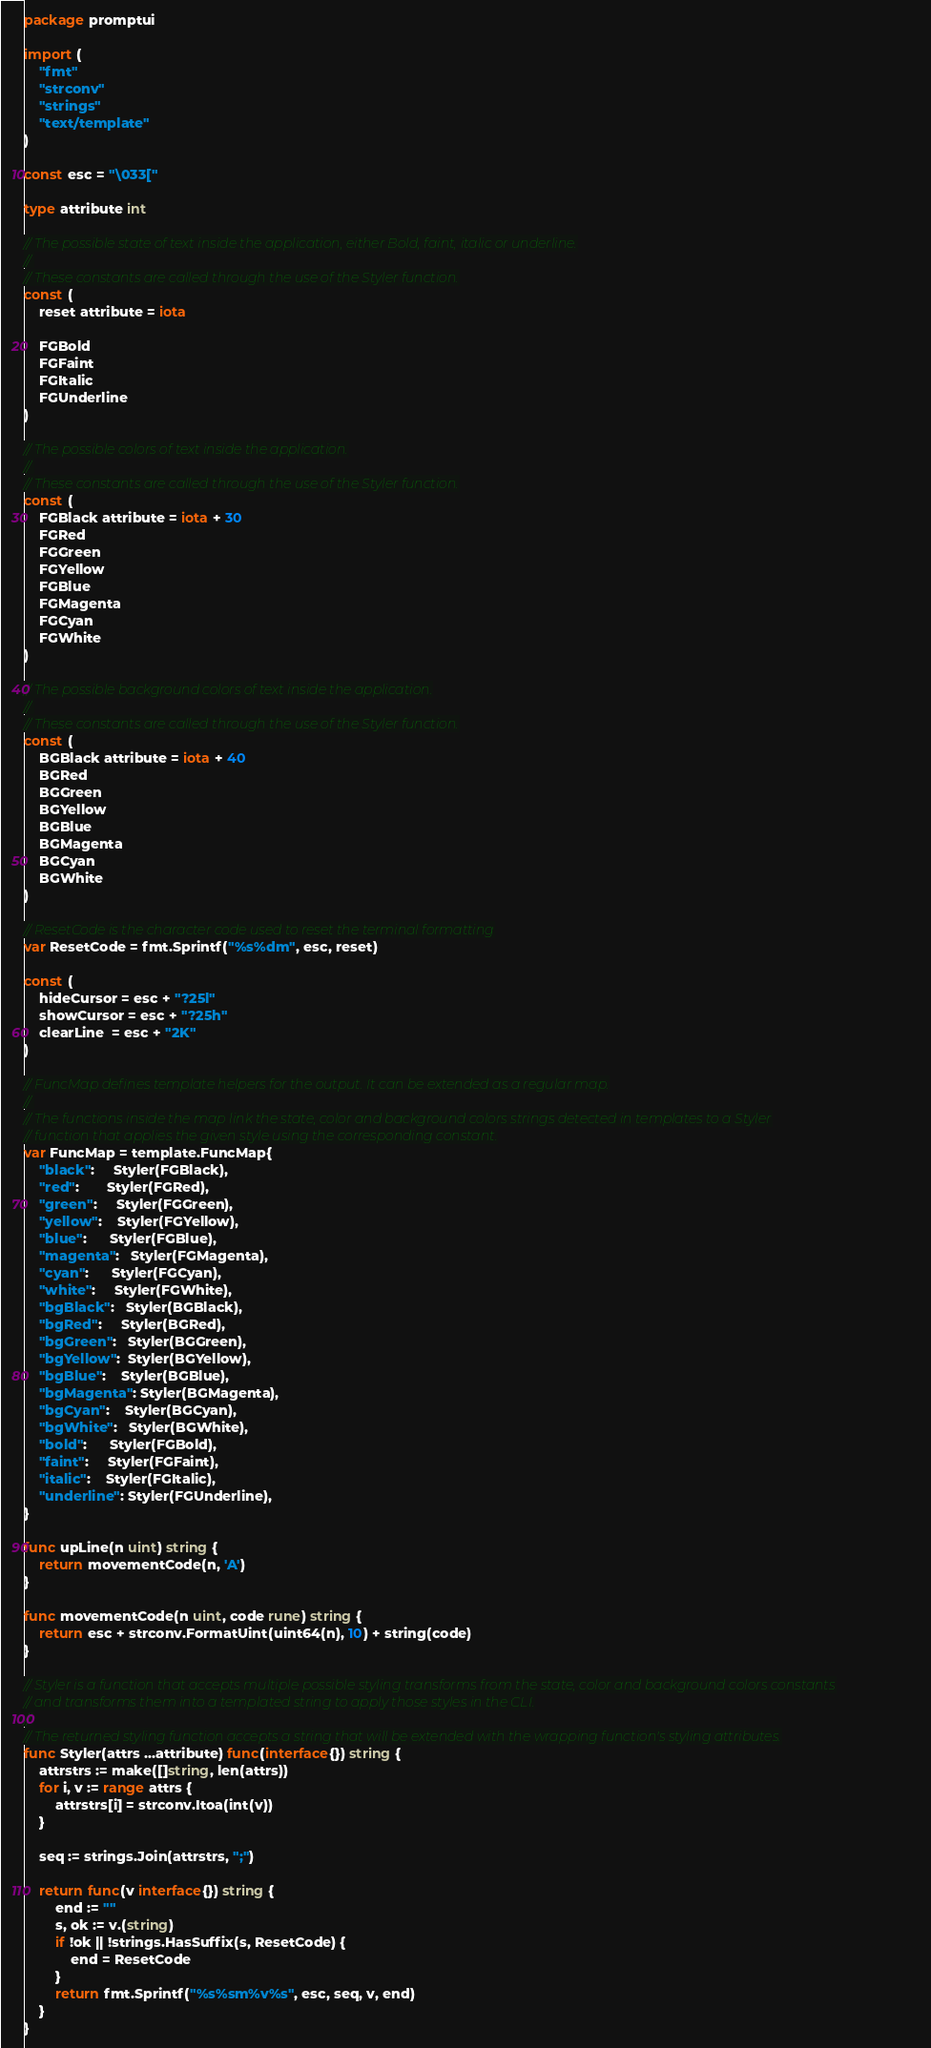<code> <loc_0><loc_0><loc_500><loc_500><_Go_>package promptui

import (
	"fmt"
	"strconv"
	"strings"
	"text/template"
)

const esc = "\033["

type attribute int

// The possible state of text inside the application, either Bold, faint, italic or underline.
//
// These constants are called through the use of the Styler function.
const (
	reset attribute = iota

	FGBold
	FGFaint
	FGItalic
	FGUnderline
)

// The possible colors of text inside the application.
//
// These constants are called through the use of the Styler function.
const (
	FGBlack attribute = iota + 30
	FGRed
	FGGreen
	FGYellow
	FGBlue
	FGMagenta
	FGCyan
	FGWhite
)

// The possible background colors of text inside the application.
//
// These constants are called through the use of the Styler function.
const (
	BGBlack attribute = iota + 40
	BGRed
	BGGreen
	BGYellow
	BGBlue
	BGMagenta
	BGCyan
	BGWhite
)

// ResetCode is the character code used to reset the terminal formatting
var ResetCode = fmt.Sprintf("%s%dm", esc, reset)

const (
	hideCursor = esc + "?25l"
	showCursor = esc + "?25h"
	clearLine  = esc + "2K"
)

// FuncMap defines template helpers for the output. It can be extended as a regular map.
//
// The functions inside the map link the state, color and background colors strings detected in templates to a Styler
// function that applies the given style using the corresponding constant.
var FuncMap = template.FuncMap{
	"black":     Styler(FGBlack),
	"red":       Styler(FGRed),
	"green":     Styler(FGGreen),
	"yellow":    Styler(FGYellow),
	"blue":      Styler(FGBlue),
	"magenta":   Styler(FGMagenta),
	"cyan":      Styler(FGCyan),
	"white":     Styler(FGWhite),
	"bgBlack":   Styler(BGBlack),
	"bgRed":     Styler(BGRed),
	"bgGreen":   Styler(BGGreen),
	"bgYellow":  Styler(BGYellow),
	"bgBlue":    Styler(BGBlue),
	"bgMagenta": Styler(BGMagenta),
	"bgCyan":    Styler(BGCyan),
	"bgWhite":   Styler(BGWhite),
	"bold":      Styler(FGBold),
	"faint":     Styler(FGFaint),
	"italic":    Styler(FGItalic),
	"underline": Styler(FGUnderline),
}

func upLine(n uint) string {
	return movementCode(n, 'A')
}

func movementCode(n uint, code rune) string {
	return esc + strconv.FormatUint(uint64(n), 10) + string(code)
}

// Styler is a function that accepts multiple possible styling transforms from the state, color and background colors constants
// and transforms them into a templated string to apply those styles in the CLI.
//
// The returned styling function accepts a string that will be extended with the wrapping function's styling attributes.
func Styler(attrs ...attribute) func(interface{}) string {
	attrstrs := make([]string, len(attrs))
	for i, v := range attrs {
		attrstrs[i] = strconv.Itoa(int(v))
	}

	seq := strings.Join(attrstrs, ";")

	return func(v interface{}) string {
		end := ""
		s, ok := v.(string)
		if !ok || !strings.HasSuffix(s, ResetCode) {
			end = ResetCode
		}
		return fmt.Sprintf("%s%sm%v%s", esc, seq, v, end)
	}
}
</code> 